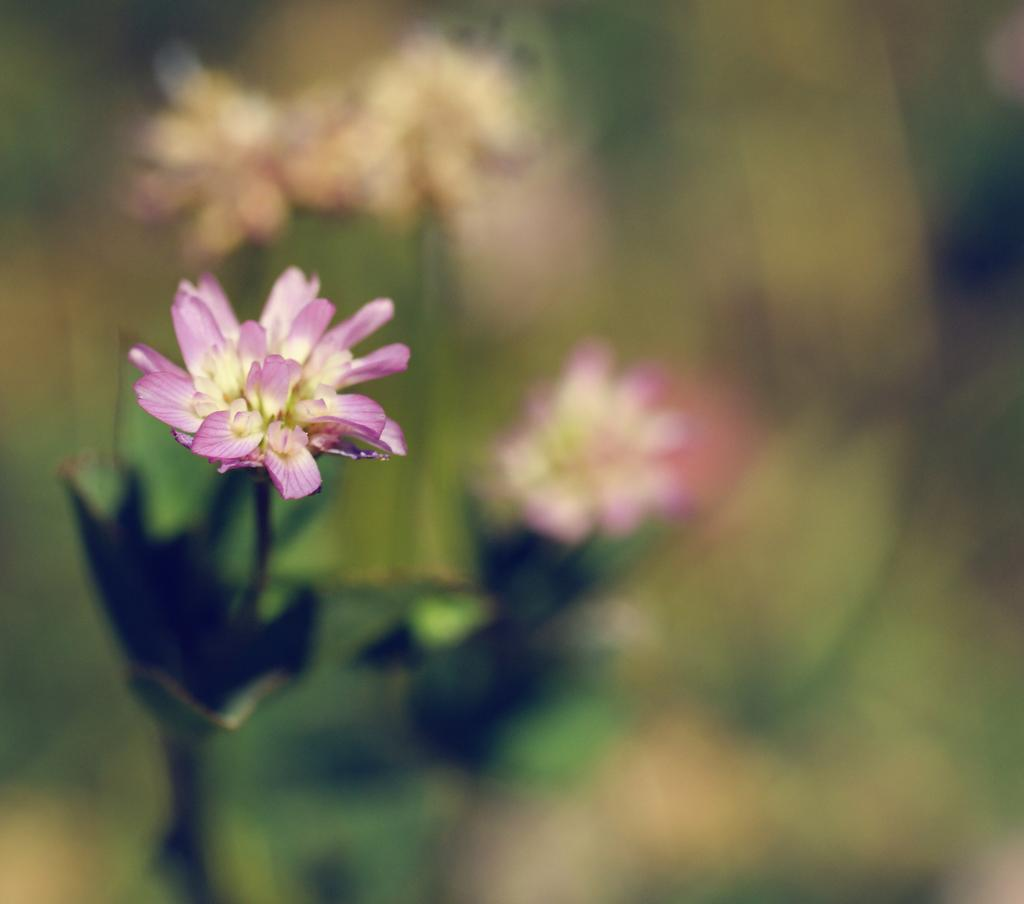What is the main subject of the image? There is a flower in the image. Can you describe the flower's origin? The flower belongs to a plant. What type of office furniture can be seen in the image? There is no office furniture present in the image, as it features a flower and its plant. How many wrens are perched on the flower in the image? There are no wrens present in the image; it only features a flower and its plant. 